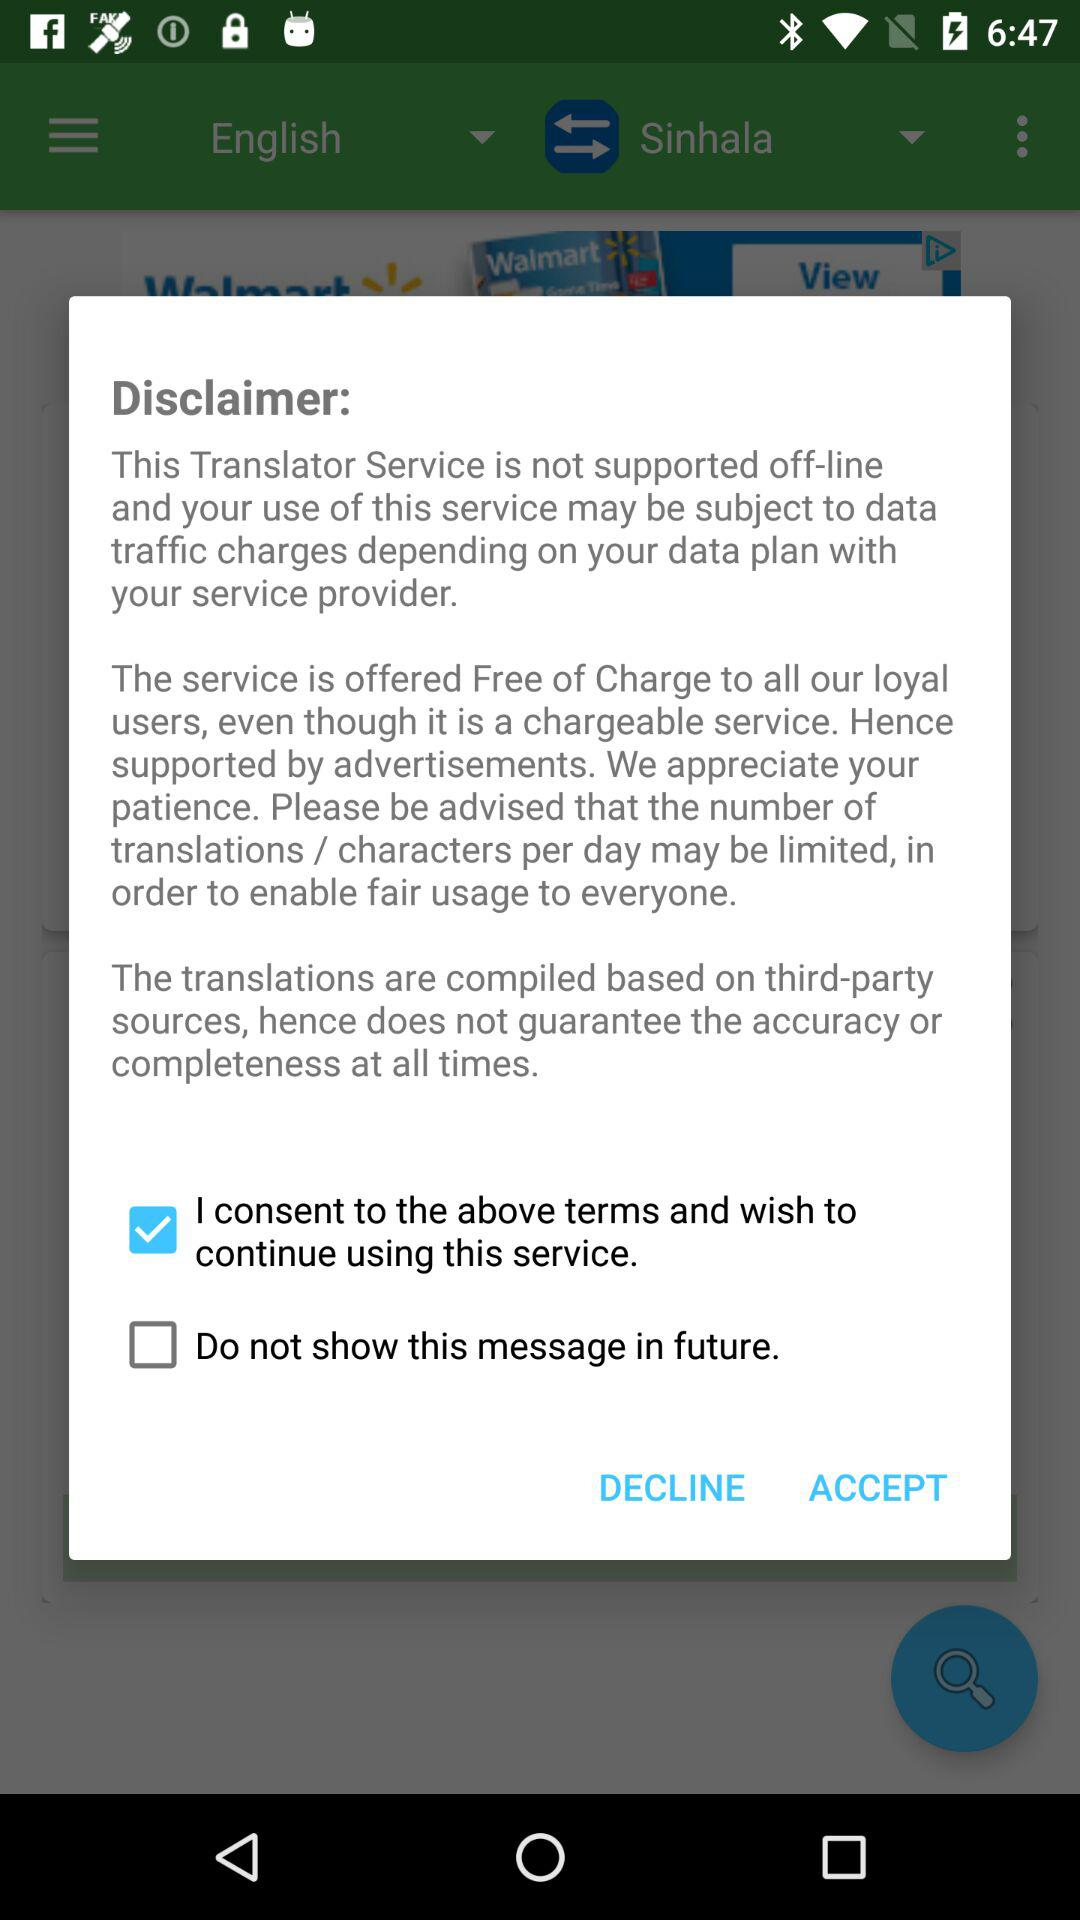What is the status of "Do not show this message in future."? The status of "Do not show this message in future." is "off". 